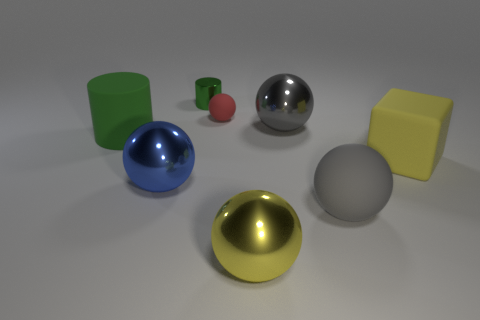Subtract all blue spheres. How many spheres are left? 4 Subtract all gray spheres. How many spheres are left? 3 Add 1 large yellow cubes. How many objects exist? 9 Subtract all cyan spheres. Subtract all green blocks. How many spheres are left? 5 Subtract all cylinders. How many objects are left? 6 Add 8 cylinders. How many cylinders are left? 10 Add 4 tiny yellow rubber objects. How many tiny yellow rubber objects exist? 4 Subtract 0 blue blocks. How many objects are left? 8 Subtract all balls. Subtract all small green shiny cylinders. How many objects are left? 2 